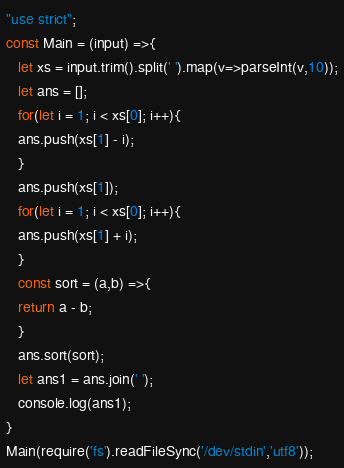Convert code to text. <code><loc_0><loc_0><loc_500><loc_500><_JavaScript_>"use strict";
const Main = (input) =>{
   let xs = input.trim().split(' ').map(v=>parseInt(v,10));
   let ans = [];
   for(let i = 1; i < xs[0]; i++){
   ans.push(xs[1] - i);
   }
   ans.push(xs[1]);  
   for(let i = 1; i < xs[0]; i++){
   ans.push(xs[1] + i);
   }
   const sort = (a,b) =>{
   return a - b;
   }
   ans.sort(sort);
   let ans1 = ans.join(' ');
   console.log(ans1);
}
Main(require('fs').readFileSync('/dev/stdin','utf8'));</code> 